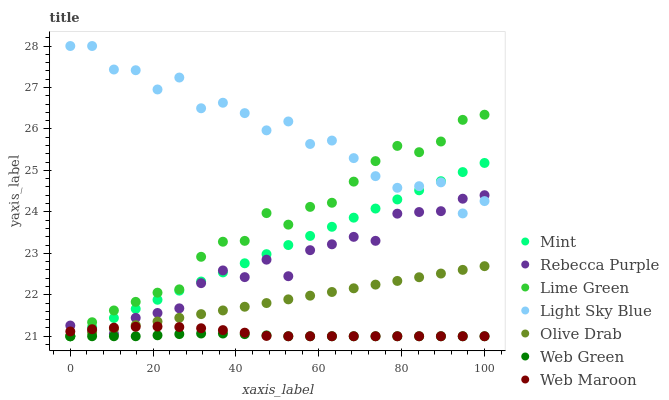Does Web Green have the minimum area under the curve?
Answer yes or no. Yes. Does Light Sky Blue have the maximum area under the curve?
Answer yes or no. Yes. Does Web Maroon have the minimum area under the curve?
Answer yes or no. No. Does Web Maroon have the maximum area under the curve?
Answer yes or no. No. Is Mint the smoothest?
Answer yes or no. Yes. Is Light Sky Blue the roughest?
Answer yes or no. Yes. Is Web Maroon the smoothest?
Answer yes or no. No. Is Web Maroon the roughest?
Answer yes or no. No. Does Mint have the lowest value?
Answer yes or no. Yes. Does Light Sky Blue have the lowest value?
Answer yes or no. No. Does Light Sky Blue have the highest value?
Answer yes or no. Yes. Does Web Maroon have the highest value?
Answer yes or no. No. Is Olive Drab less than Light Sky Blue?
Answer yes or no. Yes. Is Light Sky Blue greater than Olive Drab?
Answer yes or no. Yes. Does Web Maroon intersect Rebecca Purple?
Answer yes or no. Yes. Is Web Maroon less than Rebecca Purple?
Answer yes or no. No. Is Web Maroon greater than Rebecca Purple?
Answer yes or no. No. Does Olive Drab intersect Light Sky Blue?
Answer yes or no. No. 